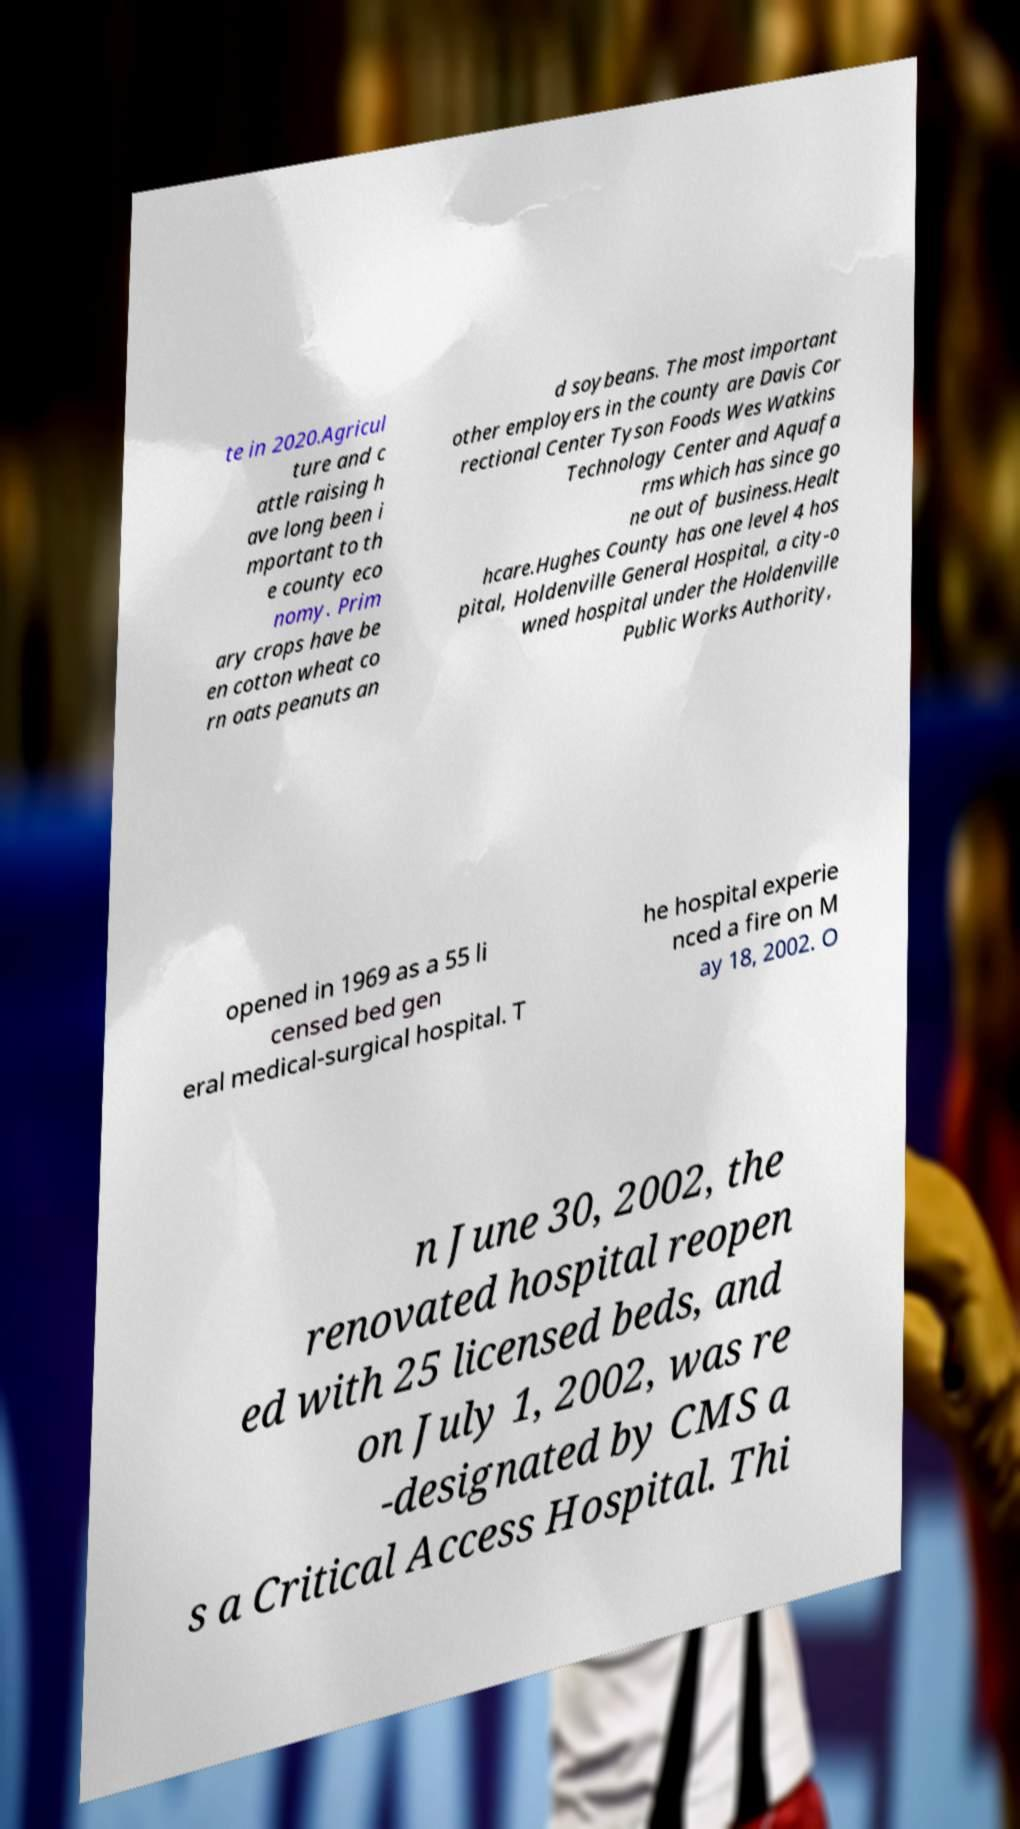Could you assist in decoding the text presented in this image and type it out clearly? te in 2020.Agricul ture and c attle raising h ave long been i mportant to th e county eco nomy. Prim ary crops have be en cotton wheat co rn oats peanuts an d soybeans. The most important other employers in the county are Davis Cor rectional Center Tyson Foods Wes Watkins Technology Center and Aquafa rms which has since go ne out of business.Healt hcare.Hughes County has one level 4 hos pital, Holdenville General Hospital, a city-o wned hospital under the Holdenville Public Works Authority, opened in 1969 as a 55 li censed bed gen eral medical-surgical hospital. T he hospital experie nced a fire on M ay 18, 2002. O n June 30, 2002, the renovated hospital reopen ed with 25 licensed beds, and on July 1, 2002, was re -designated by CMS a s a Critical Access Hospital. Thi 